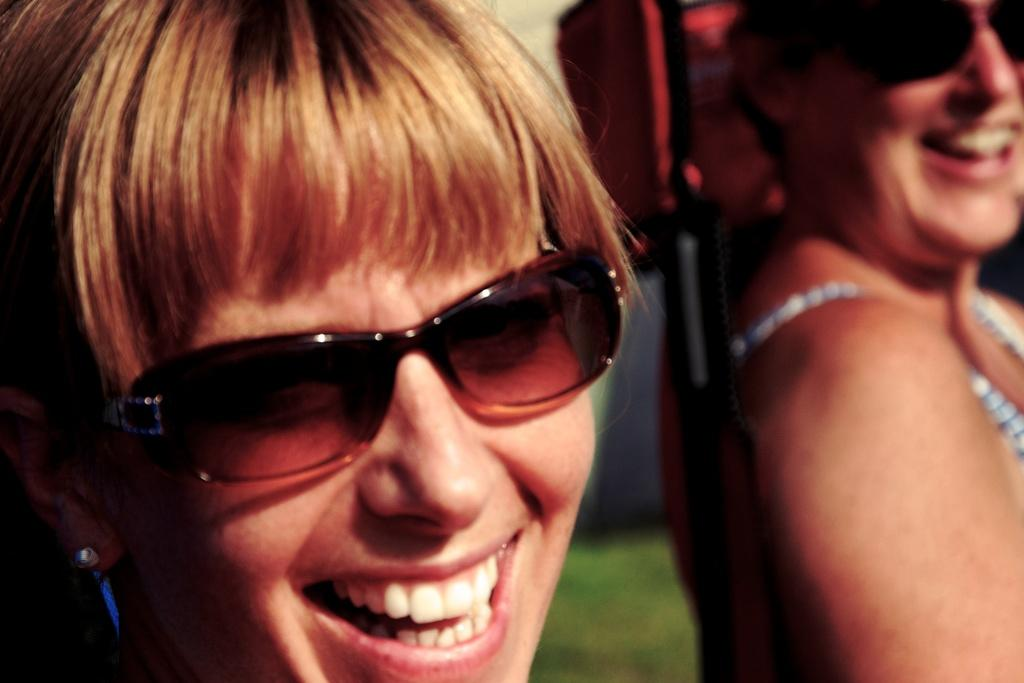Who are the main subjects in the image? There are women in the center of the image. What type of surface is visible at the bottom of the image? There is grass at the bottom of the image. What type of lamp is hanging above the women in the image? There is no lamp present in the image; it only features women and grass. Where might the women be going, considering the presence of an airport? There is no mention of an airport in the image or the provided facts, so it cannot be determined where the women might be going. 